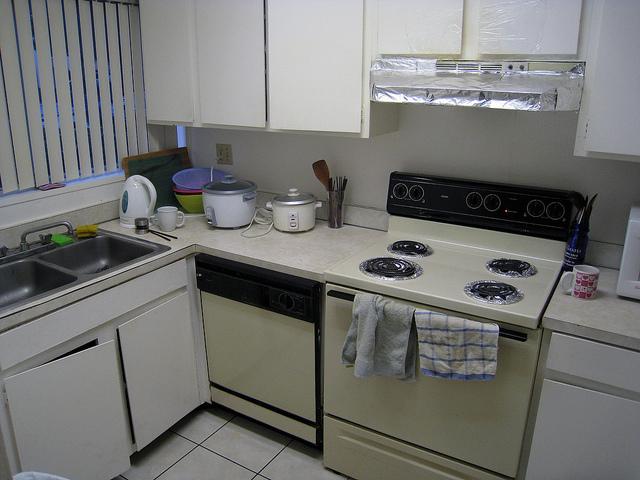What color are the cabinets?
Keep it brief. White. Is this a gas or electric stove?
Give a very brief answer. Electric. Would this be considered a modern kitchen in America?
Concise answer only. No. How many pots are on the stove?
Quick response, please. 0. How many black knobs are there?
Concise answer only. 6. Is the food ready to eat?
Write a very short answer. No. In what shape are the paper towels folded?
Concise answer only. Square. Is the slow cooker making a meal?
Write a very short answer. Yes. Is that a range or coil stove?
Keep it brief. Coil. 